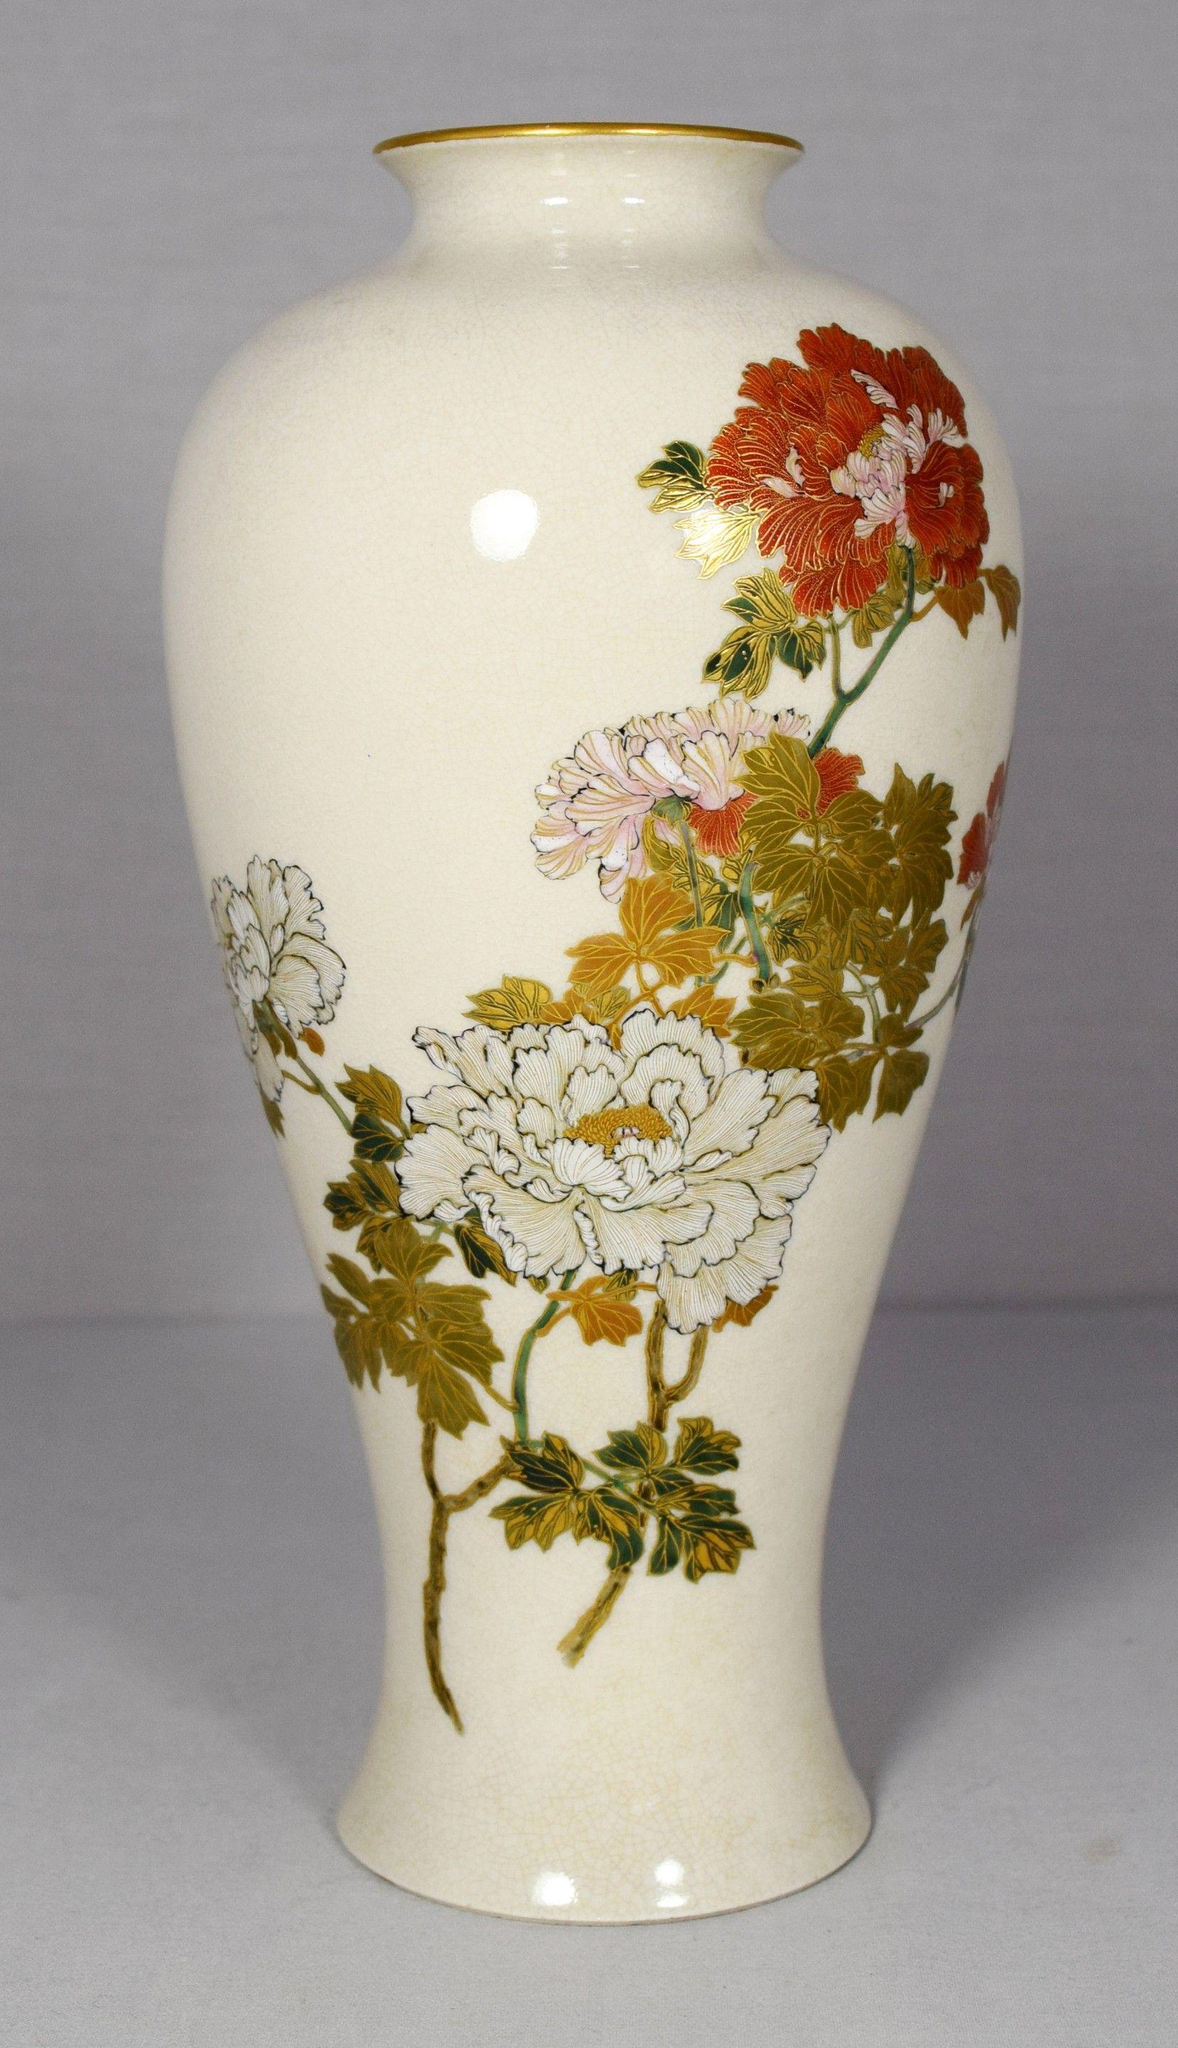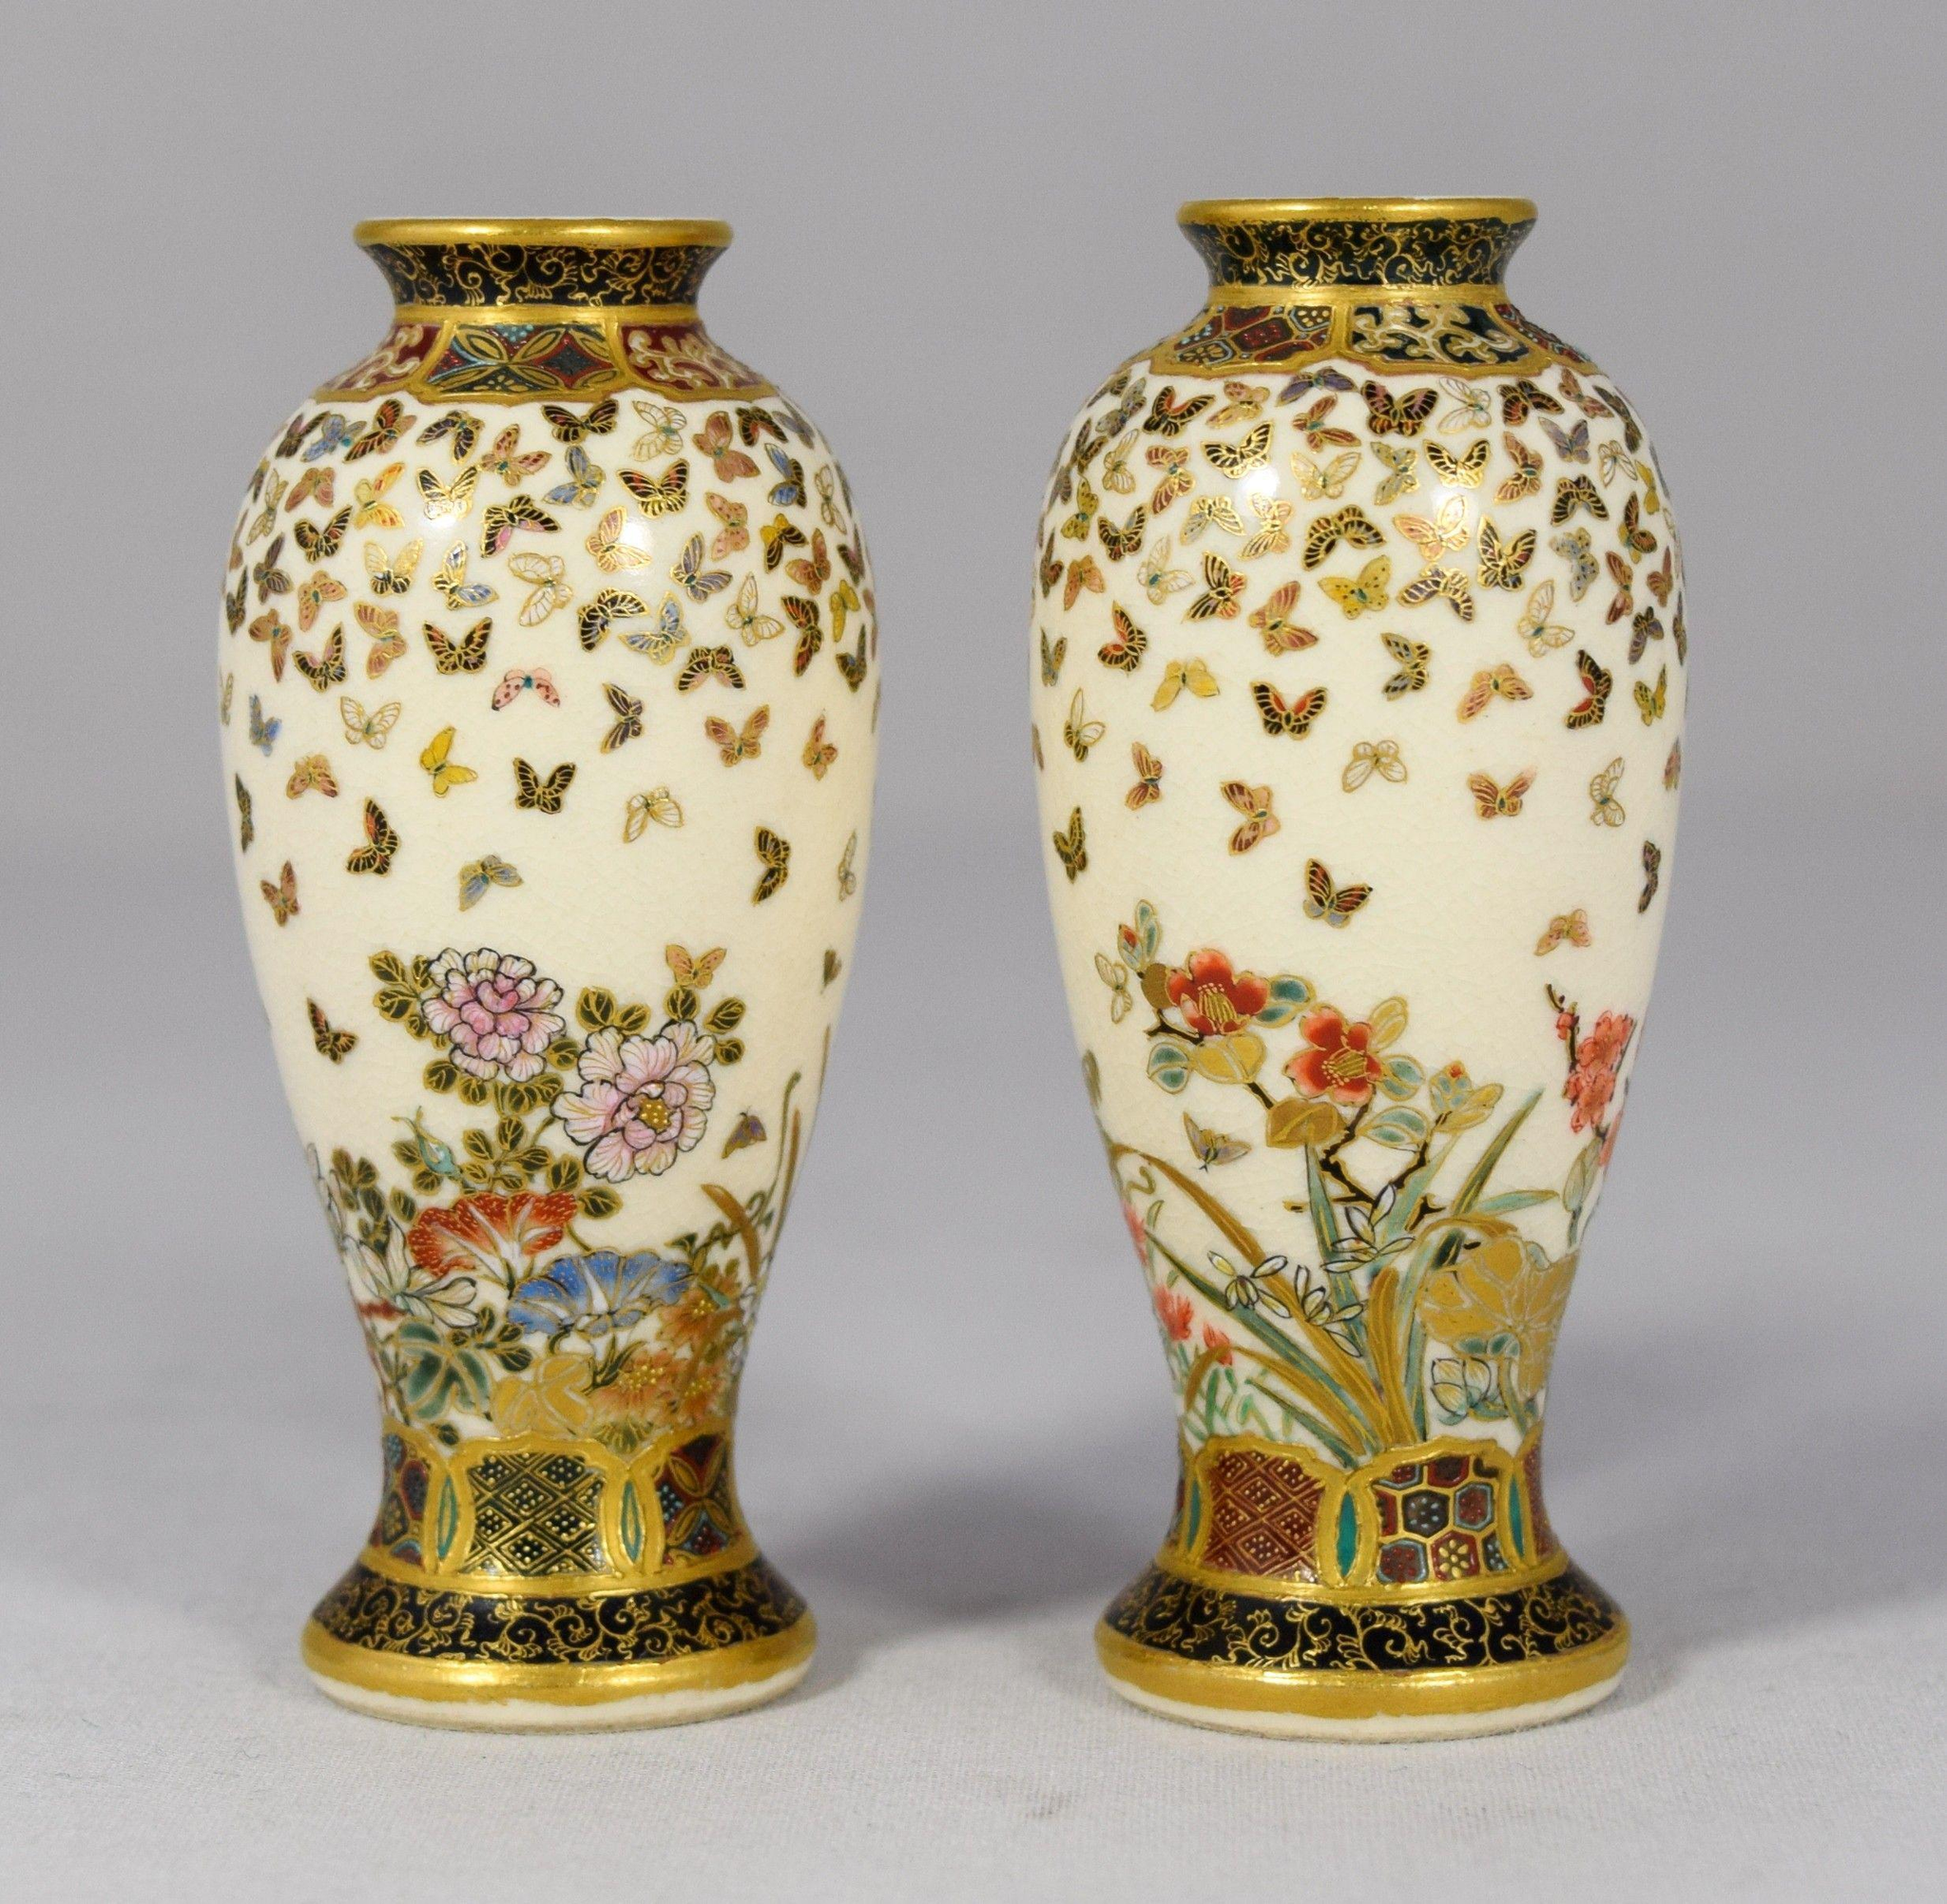The first image is the image on the left, the second image is the image on the right. Analyze the images presented: Is the assertion "There is a vase with a lot of blue on it with a wide bottom and a skinny neck at the top." valid? Answer yes or no. No. 